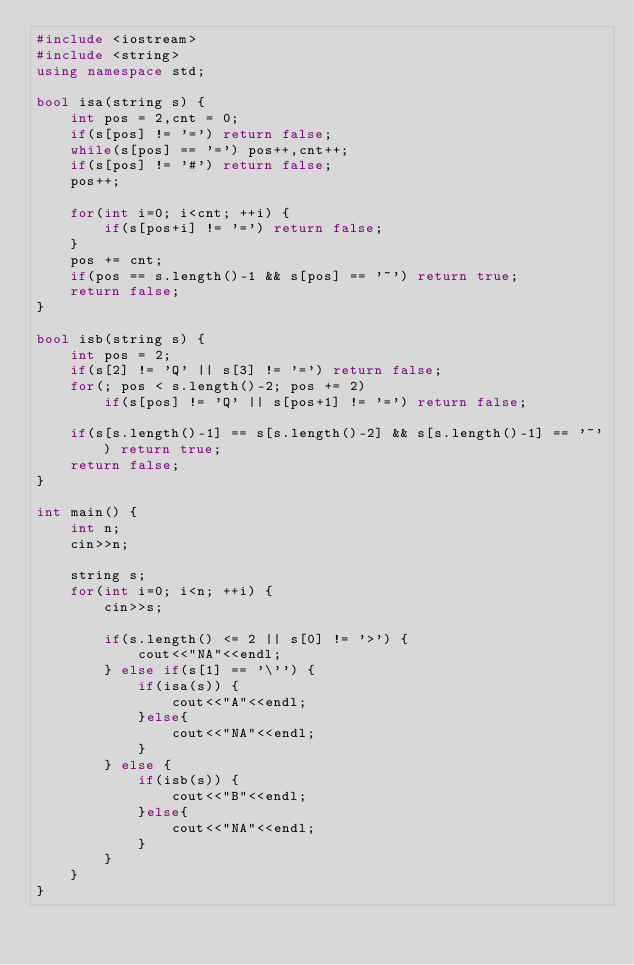Convert code to text. <code><loc_0><loc_0><loc_500><loc_500><_C++_>#include <iostream>
#include <string>
using namespace std;

bool isa(string s) {
    int pos = 2,cnt = 0;
    if(s[pos] != '=') return false;
    while(s[pos] == '=') pos++,cnt++;
    if(s[pos] != '#') return false;
    pos++;

    for(int i=0; i<cnt; ++i) {
        if(s[pos+i] != '=') return false;
    }
    pos += cnt;
    if(pos == s.length()-1 && s[pos] == '~') return true;
    return false;
}

bool isb(string s) {
    int pos = 2;
    if(s[2] != 'Q' || s[3] != '=') return false;
    for(; pos < s.length()-2; pos += 2)
        if(s[pos] != 'Q' || s[pos+1] != '=') return false;

    if(s[s.length()-1] == s[s.length()-2] && s[s.length()-1] == '~') return true;
    return false;
}

int main() {
    int n;
    cin>>n;

    string s;
    for(int i=0; i<n; ++i) {
        cin>>s;

        if(s.length() <= 2 || s[0] != '>') {
            cout<<"NA"<<endl;
        } else if(s[1] == '\'') {
            if(isa(s)) {
                cout<<"A"<<endl;
            }else{
                cout<<"NA"<<endl;
            }
        } else {
            if(isb(s)) {
                cout<<"B"<<endl;
            }else{
                cout<<"NA"<<endl;
            }
        }
    }
}</code> 